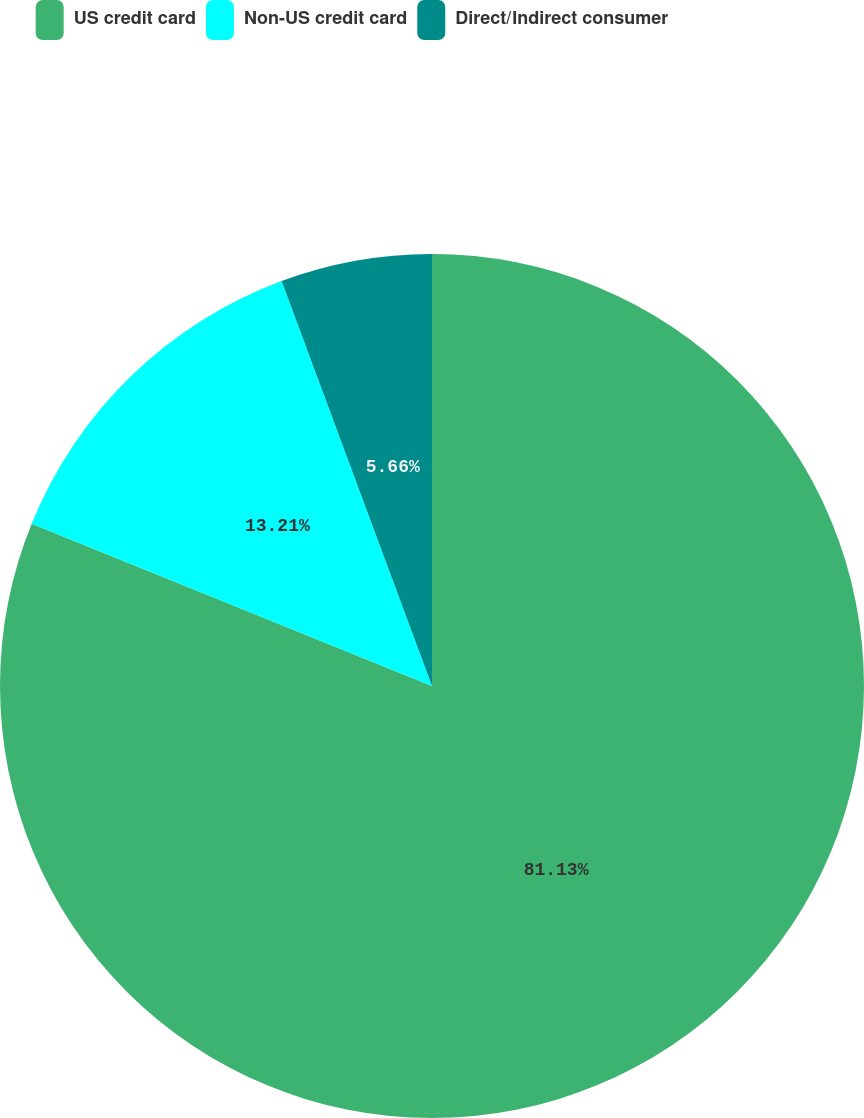<chart> <loc_0><loc_0><loc_500><loc_500><pie_chart><fcel>US credit card<fcel>Non-US credit card<fcel>Direct/Indirect consumer<nl><fcel>81.13%<fcel>13.21%<fcel>5.66%<nl></chart> 